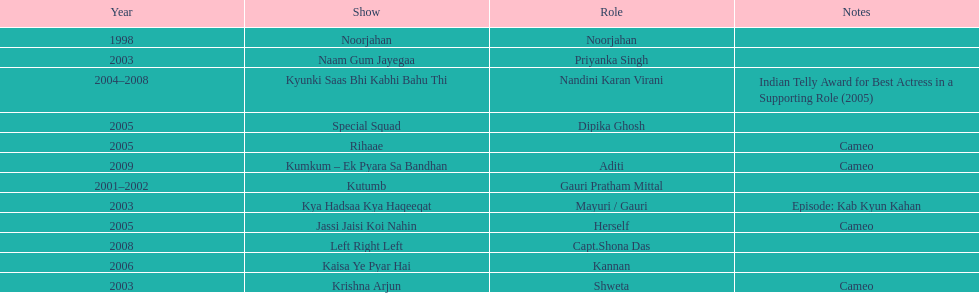Besides rihaae, in what other show did gauri tejwani cameo in 2005? Jassi Jaisi Koi Nahin. 